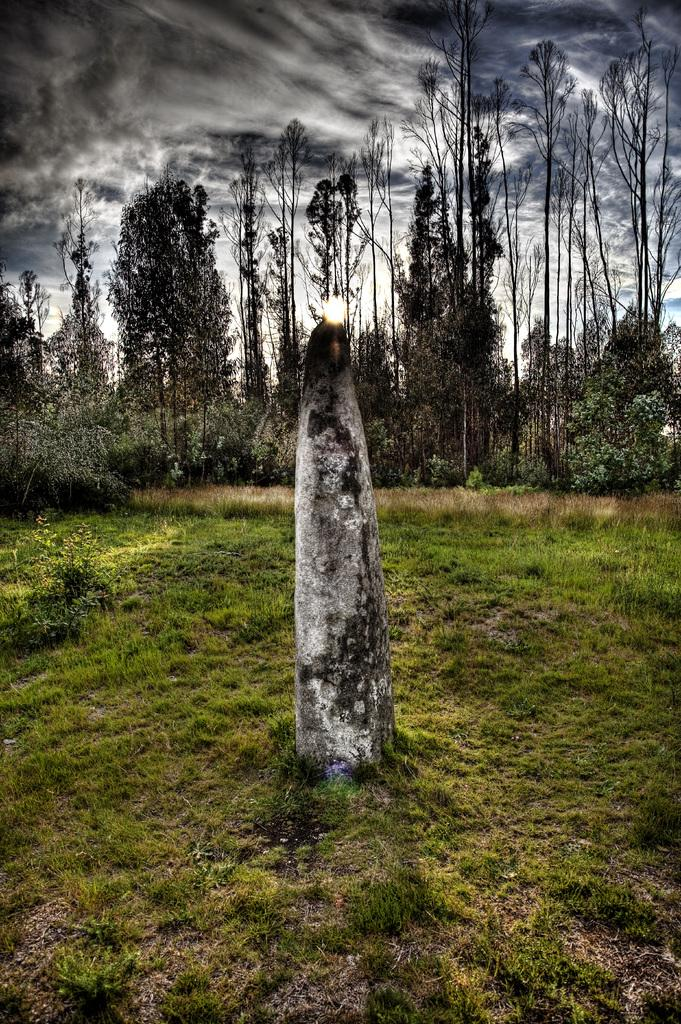What is the main subject in the center of the image? There is a stone in the center of the image. Where is the stone located? The stone is on the ground. What can be seen in the background of the image? There are trees in the background of the image. What is visible in the sky at the top of the image? The sun is visible in the image, and there are clouds in the sky. How many frogs are sitting on the stone in the image? There are no frogs present in the image; it only features a stone on the ground. What type of lock is used to secure the stone in the image? There is no lock present in the image; the stone is simply resting on the ground. 